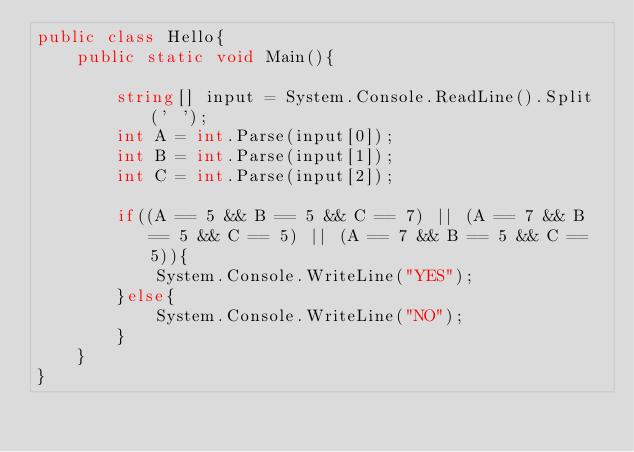<code> <loc_0><loc_0><loc_500><loc_500><_C#_>public class Hello{
    public static void Main(){

        string[] input = System.Console.ReadLine().Split(' ');
        int A = int.Parse(input[0]);
        int B = int.Parse(input[1]);
        int C = int.Parse(input[2]);
        
        if((A == 5 && B == 5 && C == 7) || (A == 7 && B == 5 && C == 5) || (A == 7 && B == 5 && C == 5)){
            System.Console.WriteLine("YES");
        }else{
            System.Console.WriteLine("NO");
        }
    }
}
</code> 